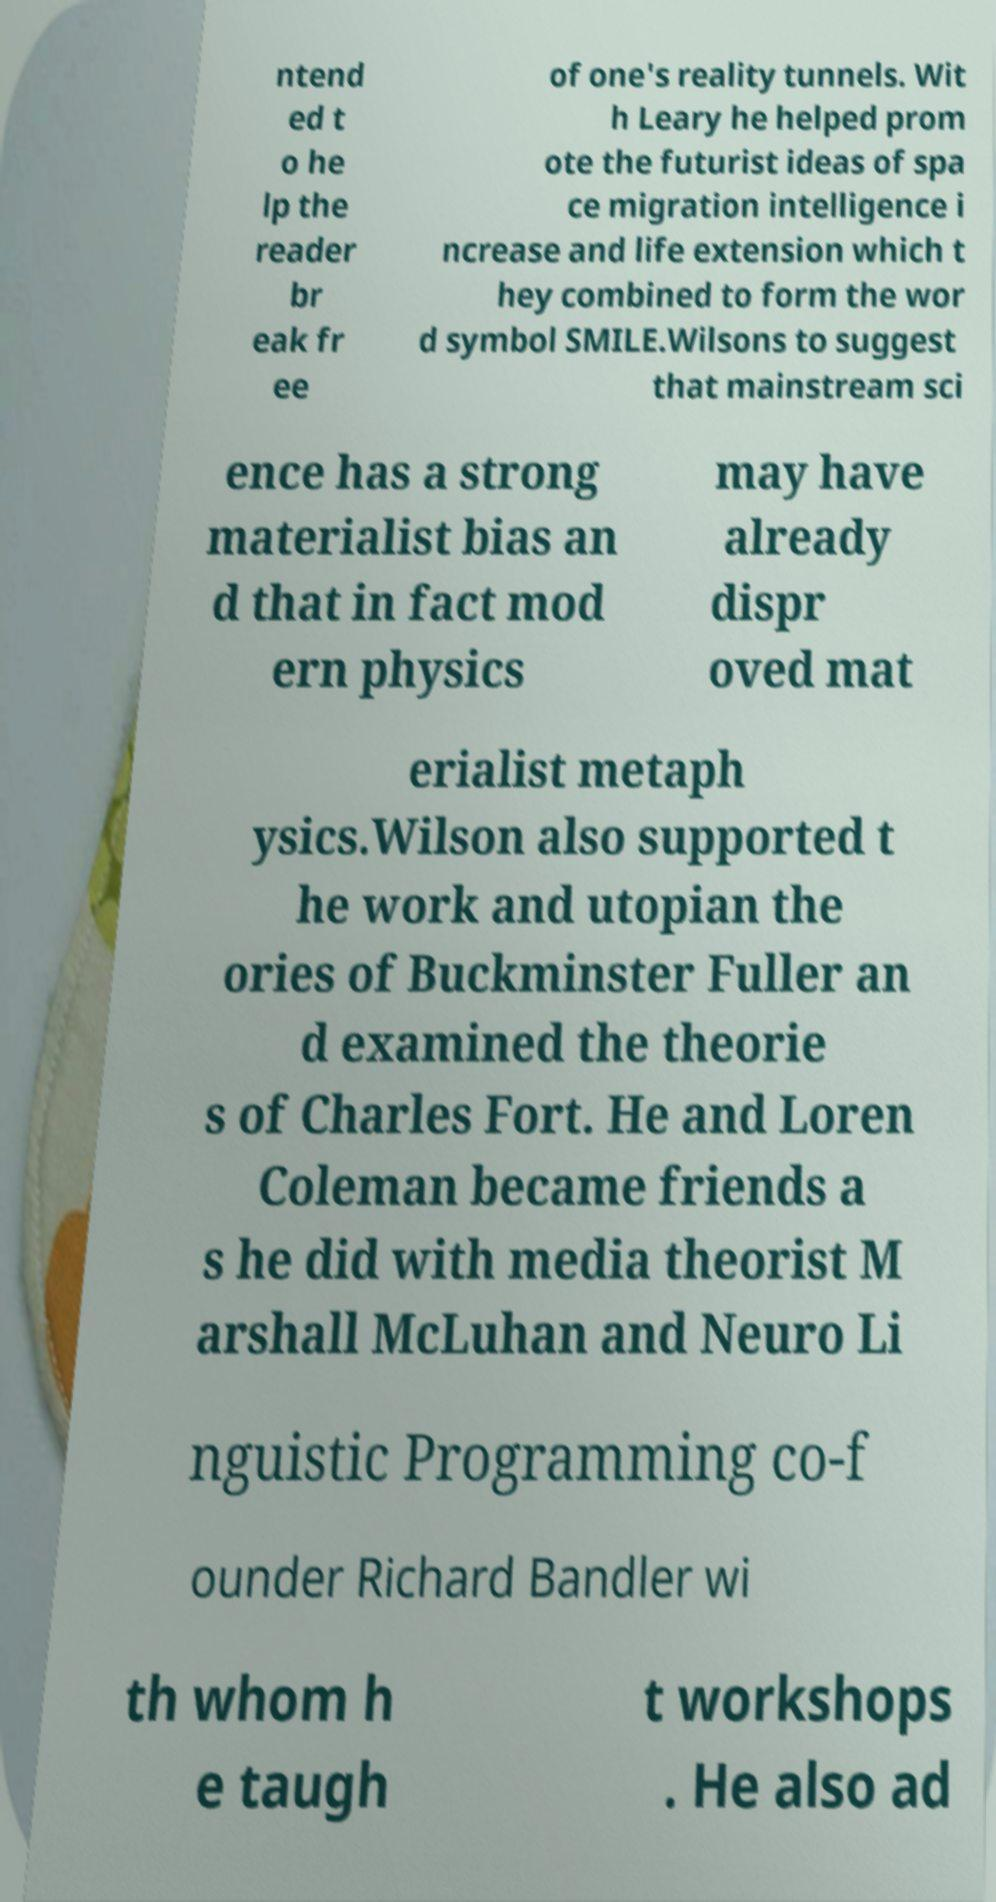What messages or text are displayed in this image? I need them in a readable, typed format. ntend ed t o he lp the reader br eak fr ee of one's reality tunnels. Wit h Leary he helped prom ote the futurist ideas of spa ce migration intelligence i ncrease and life extension which t hey combined to form the wor d symbol SMILE.Wilsons to suggest that mainstream sci ence has a strong materialist bias an d that in fact mod ern physics may have already dispr oved mat erialist metaph ysics.Wilson also supported t he work and utopian the ories of Buckminster Fuller an d examined the theorie s of Charles Fort. He and Loren Coleman became friends a s he did with media theorist M arshall McLuhan and Neuro Li nguistic Programming co-f ounder Richard Bandler wi th whom h e taugh t workshops . He also ad 